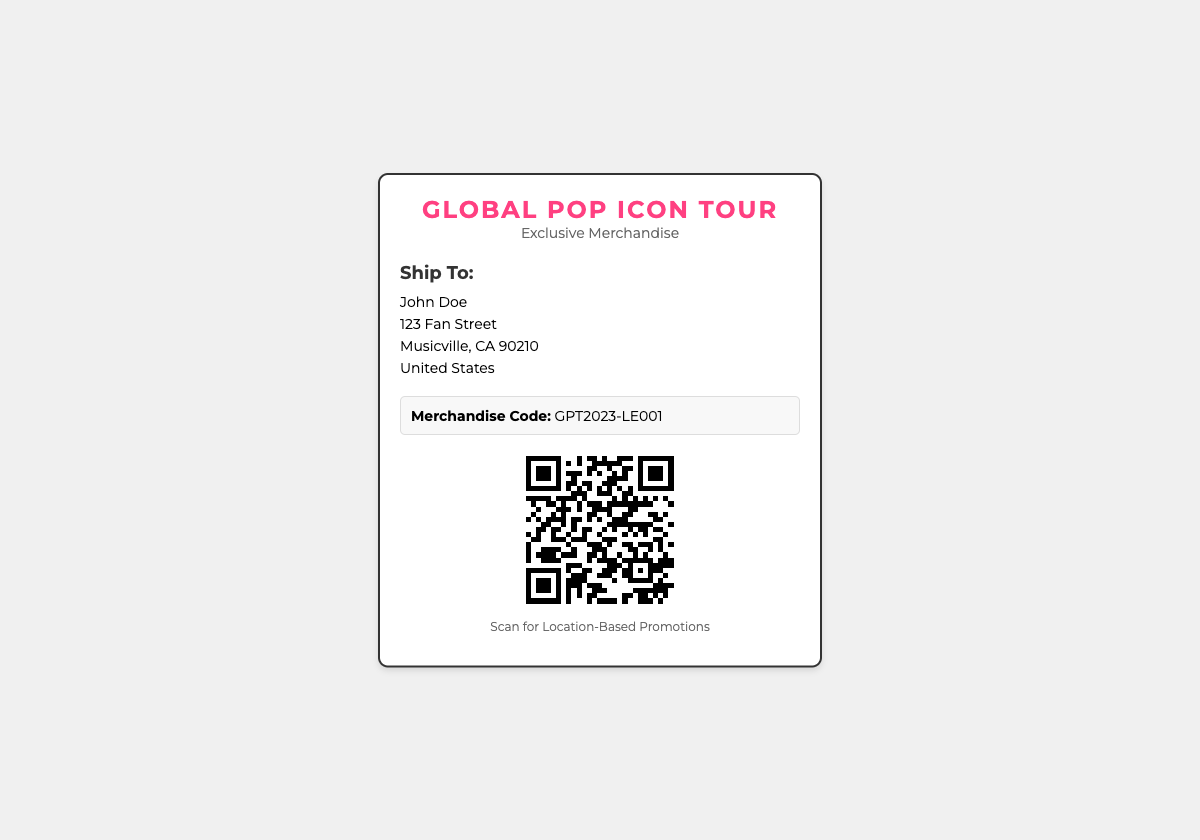What is the name of the tour? The name of the tour is prominently displayed in the header of the shipping label.
Answer: Global Pop Icon Tour Who is the recipient's name? The recipient's name is listed directly under "Ship To:" in the document.
Answer: John Doe What is the merchandise code? The merchandise code is specified in the designated merchandise code section of the document.
Answer: GPT2023-LE001 What is the city of the recipient? The city is clearly mentioned in the address section for the recipient.
Answer: Musicville What does the QR code promote? The purpose of the QR code is described in the text below the code.
Answer: Location-Based Promotions How many lines are in the recipient address? The recipient address section contains the name, street address, city, and country, which are listed in separate lines.
Answer: 4 What kind of merchandise is being shipped? The type of merchandise is indicated in the subtitle of the shipping label design.
Answer: Exclusive Merchandise What style of font is used in the shipping label? The document features a specific web font style as mentioned in the CSS section.
Answer: Montserrat What is the color of the logo text? The color of the logo is specified in the CSS styling section by the color code.
Answer: #ff4081 